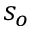<formula> <loc_0><loc_0><loc_500><loc_500>s _ { o }</formula> 